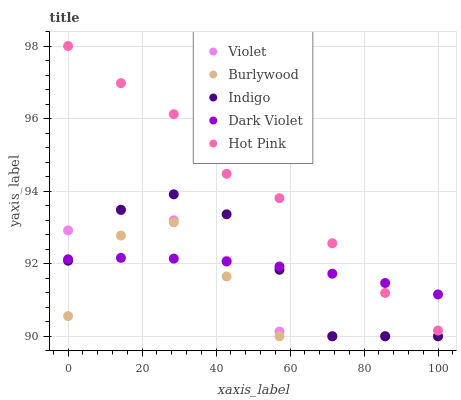Does Burlywood have the minimum area under the curve?
Answer yes or no. Yes. Does Hot Pink have the maximum area under the curve?
Answer yes or no. Yes. Does Indigo have the minimum area under the curve?
Answer yes or no. No. Does Indigo have the maximum area under the curve?
Answer yes or no. No. Is Dark Violet the smoothest?
Answer yes or no. Yes. Is Burlywood the roughest?
Answer yes or no. Yes. Is Hot Pink the smoothest?
Answer yes or no. No. Is Hot Pink the roughest?
Answer yes or no. No. Does Burlywood have the lowest value?
Answer yes or no. Yes. Does Hot Pink have the lowest value?
Answer yes or no. No. Does Hot Pink have the highest value?
Answer yes or no. Yes. Does Indigo have the highest value?
Answer yes or no. No. Is Indigo less than Hot Pink?
Answer yes or no. Yes. Is Hot Pink greater than Violet?
Answer yes or no. Yes. Does Indigo intersect Burlywood?
Answer yes or no. Yes. Is Indigo less than Burlywood?
Answer yes or no. No. Is Indigo greater than Burlywood?
Answer yes or no. No. Does Indigo intersect Hot Pink?
Answer yes or no. No. 